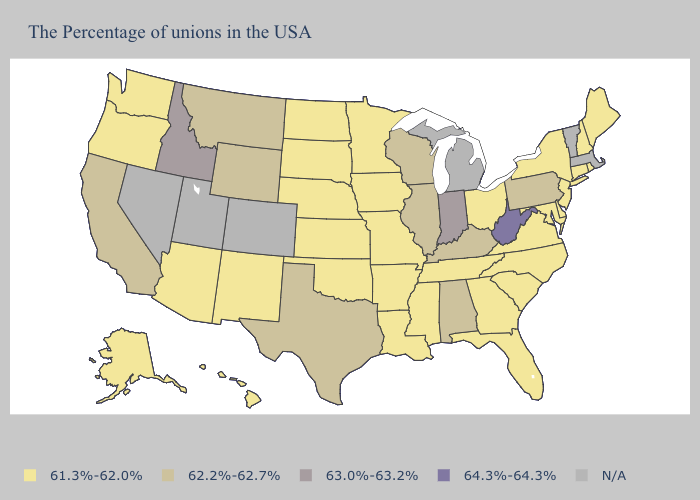Name the states that have a value in the range 61.3%-62.0%?
Short answer required. Maine, Rhode Island, New Hampshire, Connecticut, New York, New Jersey, Delaware, Maryland, Virginia, North Carolina, South Carolina, Ohio, Florida, Georgia, Tennessee, Mississippi, Louisiana, Missouri, Arkansas, Minnesota, Iowa, Kansas, Nebraska, Oklahoma, South Dakota, North Dakota, New Mexico, Arizona, Washington, Oregon, Alaska, Hawaii. Name the states that have a value in the range 61.3%-62.0%?
Short answer required. Maine, Rhode Island, New Hampshire, Connecticut, New York, New Jersey, Delaware, Maryland, Virginia, North Carolina, South Carolina, Ohio, Florida, Georgia, Tennessee, Mississippi, Louisiana, Missouri, Arkansas, Minnesota, Iowa, Kansas, Nebraska, Oklahoma, South Dakota, North Dakota, New Mexico, Arizona, Washington, Oregon, Alaska, Hawaii. What is the value of Massachusetts?
Be succinct. N/A. What is the value of Kentucky?
Be succinct. 62.2%-62.7%. Does Idaho have the highest value in the West?
Keep it brief. Yes. What is the lowest value in the USA?
Answer briefly. 61.3%-62.0%. Which states have the highest value in the USA?
Answer briefly. West Virginia. Is the legend a continuous bar?
Answer briefly. No. What is the value of Massachusetts?
Answer briefly. N/A. What is the lowest value in the South?
Answer briefly. 61.3%-62.0%. Among the states that border Illinois , which have the highest value?
Quick response, please. Indiana. What is the value of Louisiana?
Quick response, please. 61.3%-62.0%. Name the states that have a value in the range 62.2%-62.7%?
Concise answer only. Pennsylvania, Kentucky, Alabama, Wisconsin, Illinois, Texas, Wyoming, Montana, California. How many symbols are there in the legend?
Quick response, please. 5. 